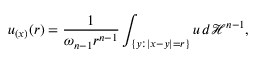<formula> <loc_0><loc_0><loc_500><loc_500>u _ { ( x ) } ( r ) = { \frac { 1 } { \omega _ { n - 1 } r ^ { n - 1 } } } \int _ { \{ y \colon | x - y | = r \} } u \, d { \mathcal { H } } ^ { n - 1 } ,</formula> 